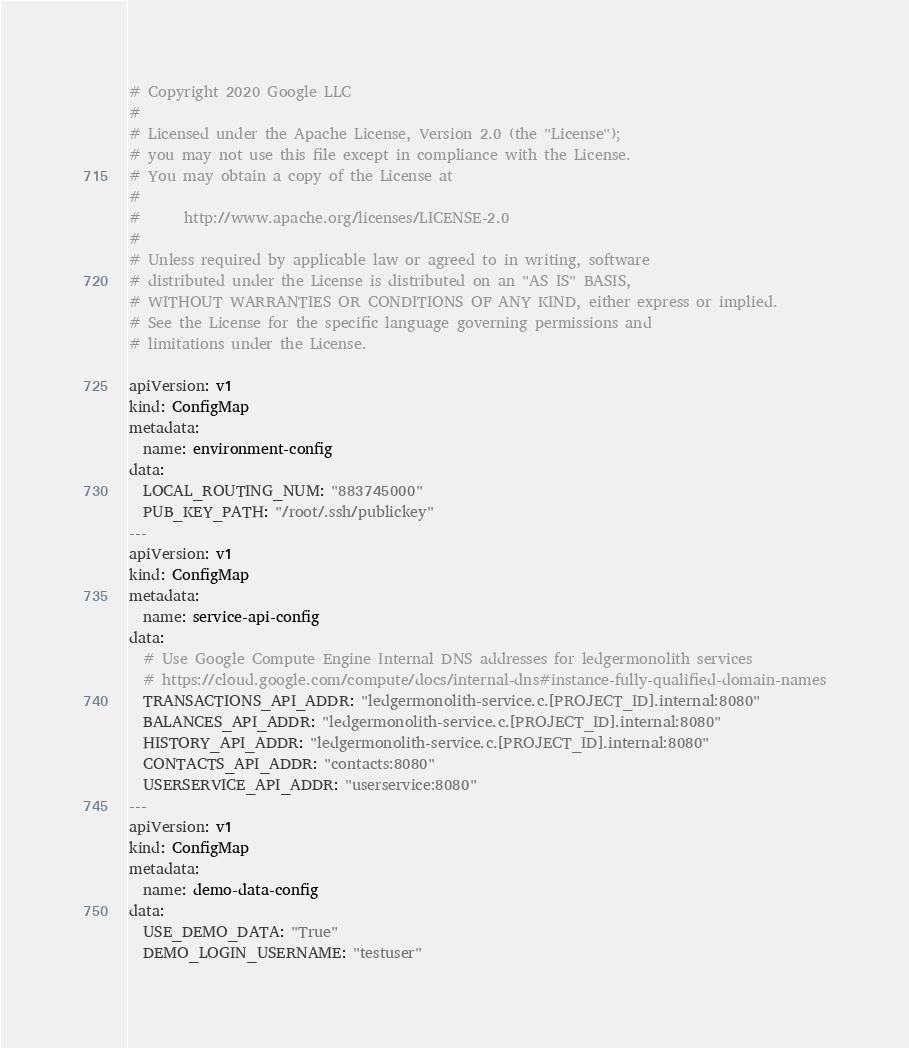Convert code to text. <code><loc_0><loc_0><loc_500><loc_500><_YAML_># Copyright 2020 Google LLC
#
# Licensed under the Apache License, Version 2.0 (the "License");
# you may not use this file except in compliance with the License.
# You may obtain a copy of the License at
#
#      http://www.apache.org/licenses/LICENSE-2.0
#
# Unless required by applicable law or agreed to in writing, software
# distributed under the License is distributed on an "AS IS" BASIS,
# WITHOUT WARRANTIES OR CONDITIONS OF ANY KIND, either express or implied.
# See the License for the specific language governing permissions and
# limitations under the License.

apiVersion: v1
kind: ConfigMap
metadata:
  name: environment-config
data:
  LOCAL_ROUTING_NUM: "883745000"
  PUB_KEY_PATH: "/root/.ssh/publickey"
---
apiVersion: v1
kind: ConfigMap
metadata:
  name: service-api-config
data:
  # Use Google Compute Engine Internal DNS addresses for ledgermonolith services
  # https://cloud.google.com/compute/docs/internal-dns#instance-fully-qualified-domain-names
  TRANSACTIONS_API_ADDR: "ledgermonolith-service.c.[PROJECT_ID].internal:8080"
  BALANCES_API_ADDR: "ledgermonolith-service.c.[PROJECT_ID].internal:8080"
  HISTORY_API_ADDR: "ledgermonolith-service.c.[PROJECT_ID].internal:8080"
  CONTACTS_API_ADDR: "contacts:8080"
  USERSERVICE_API_ADDR: "userservice:8080"
---
apiVersion: v1
kind: ConfigMap
metadata:
  name: demo-data-config
data:
  USE_DEMO_DATA: "True"
  DEMO_LOGIN_USERNAME: "testuser"</code> 